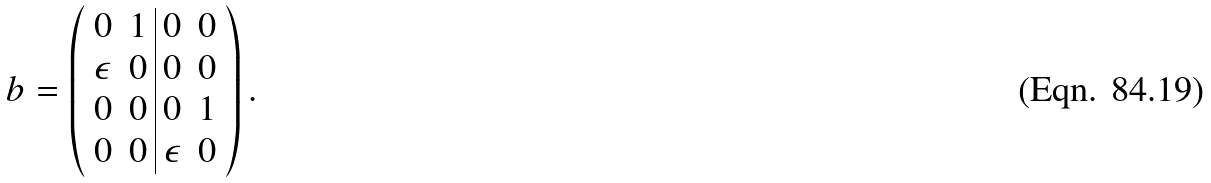Convert formula to latex. <formula><loc_0><loc_0><loc_500><loc_500>b = \left ( \begin{array} { c c | c c } 0 & 1 & 0 & 0 \\ \epsilon & 0 & 0 & 0 \\ 0 & 0 & 0 & 1 \\ 0 & 0 & \epsilon & 0 \end{array} \right ) .</formula> 